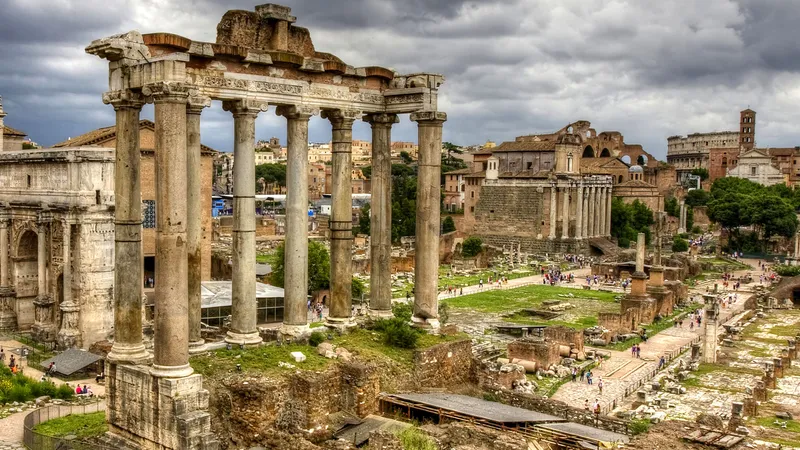What details can you provide about the structure seen in the foreground with the arches? The structure in the foreground with the arches is most likely part of the Temple of Saturn, one of the most ancient sacred sites in Rome. Built around 497 BC, the temple housed the state treasury. Its iconic Ionic columns and the remaining front section with arches have become symbols of Roman engineering prowess. This image captures its crumbling but still impressive façade, illustrating the architectural style and significance of religious and civic spaces in ancient Rome. 